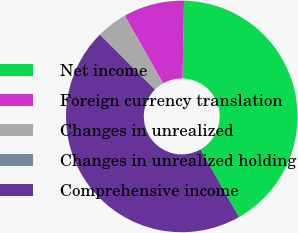Convert chart. <chart><loc_0><loc_0><loc_500><loc_500><pie_chart><fcel>Net income<fcel>Foreign currency translation<fcel>Changes in unrealized<fcel>Changes in unrealized holding<fcel>Comprehensive income<nl><fcel>41.46%<fcel>8.52%<fcel>4.28%<fcel>0.04%<fcel>45.7%<nl></chart> 